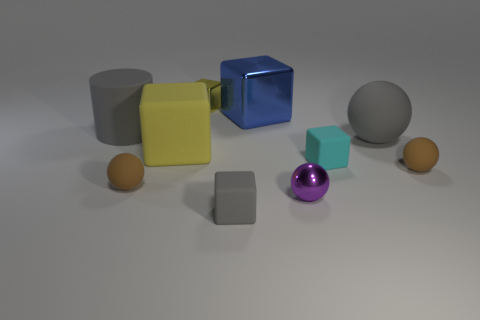Is the number of big purple metallic cylinders less than the number of small spheres?
Offer a very short reply. Yes. What size is the thing that is both to the right of the blue shiny block and on the left side of the cyan matte object?
Your answer should be very brief. Small. How big is the brown thing that is on the right side of the tiny shiny object on the right side of the gray cube that is in front of the large ball?
Offer a very short reply. Small. How many other objects are there of the same color as the big matte ball?
Give a very brief answer. 2. Is the color of the large rubber cube to the left of the tiny purple metallic ball the same as the small shiny block?
Offer a terse response. Yes. How many things are big yellow cylinders or gray matte spheres?
Make the answer very short. 1. What is the color of the tiny metallic thing in front of the cyan cube?
Your response must be concise. Purple. Is the number of small metallic things behind the yellow matte thing less than the number of small brown objects?
Provide a short and direct response. Yes. What is the size of the rubber cylinder that is the same color as the large sphere?
Give a very brief answer. Large. Do the tiny yellow thing and the large blue object have the same material?
Keep it short and to the point. Yes. 